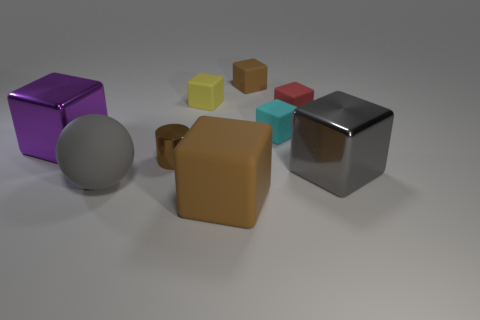Could you describe the possible functions or symbolic meanings attributed to the different shapes observed in the image? Certainly! The objects could be interpreted in multiple ways. The cylinders might symbolize industrial elements, often associated with machinery. Cubes can represent stability and order, as they are a fundamental construction shape. The sphere's smoothness often symbolizes unity and wholeness. The variety of shapes might suggest a thematic contrast between organic and industrial forms or perhaps a demonstration of basic geometrical forms for educational purposes. 